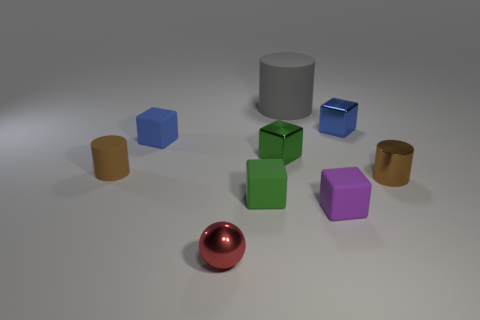What do the different colors of the objects tell us about the scene? The varied hues add contrast and visual interest, which may indicate this is a setting designed to be vibrant and engaging, potentially for educational or demonstrative purposes, showcasing color variety and object geometry. 